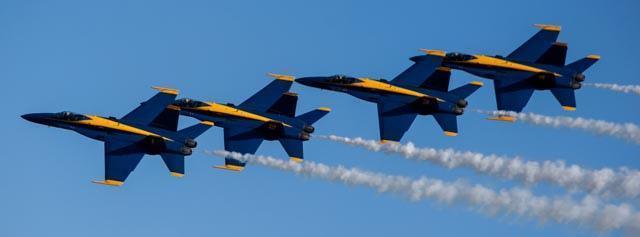How many planes are visible?
Give a very brief answer. 4. How many airplanes can you see?
Give a very brief answer. 4. How many people are wearing red shoes?
Give a very brief answer. 0. 